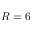Convert formula to latex. <formula><loc_0><loc_0><loc_500><loc_500>R = 6</formula> 